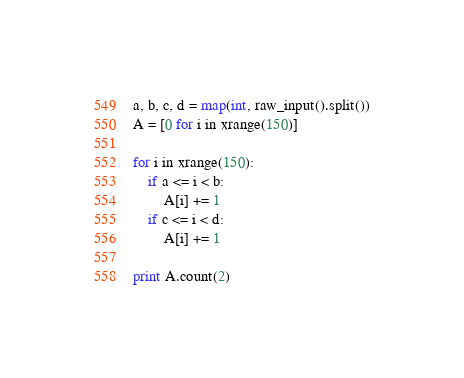<code> <loc_0><loc_0><loc_500><loc_500><_Python_>a, b, c, d = map(int, raw_input().split())
A = [0 for i in xrange(150)]

for i in xrange(150):
    if a <= i < b:
        A[i] += 1
    if c <= i < d:
        A[i] += 1

print A.count(2)
</code> 